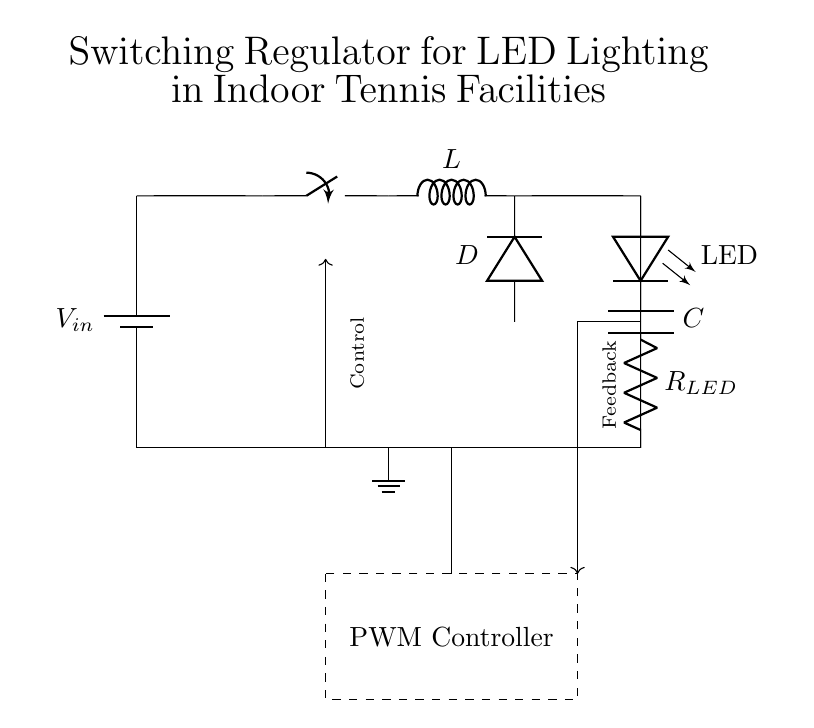What is the primary function of the inductor in this circuit? The inductor stores energy when the switch is closed and releases it when the switch is opened, which is essential for regulating the output voltage to the LED.
Answer: Energy storage What is the role of the diode in this circuit? The diode allows current to flow in one direction only, preventing it from flowing back into the inductor when the switch is opened, which ensures that the load receives a consistent current.
Answer: Current direction What component is responsible for controlling the power delivered to the LED? The PWM controller adjusts the duty cycle of the switch operation, which controls the average power and brightness of the LED by regulating the voltage applied to it.
Answer: PWM controller How many main components does the circuit have? Counting the battery, switch, inductor, diode, capacitor, resistor, and LED, we have seven main components in total.
Answer: Seven components What type of regulator is implemented in this circuit? This circuit utilizes a switching regulator design, which is characterized by the use of a switch to control the energy flow and regulate the output voltage efficiently.
Answer: Switching regulator What does the feedback mechanism do in this circuit? The feedback mechanism identifies the LED's voltage level and provides information back to the PWM controller, allowing it to adjust the switching action to stabilize the output voltage and maintain desired brightness.
Answer: Voltage stabilization What is the purpose of the capacitor in this circuit? The capacitor smooths out the output voltage by filtering the current delivered to the LED, reducing voltage ripple and ensuring a steady output for uniform brightness.
Answer: Voltage smoothing 